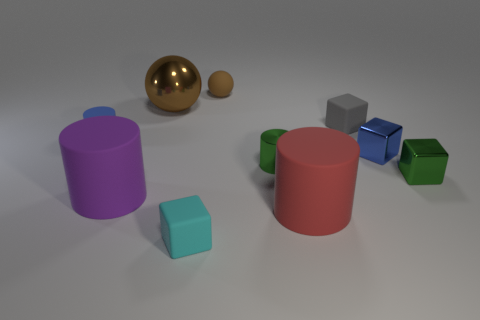Subtract 1 cubes. How many cubes are left? 3 Subtract all balls. How many objects are left? 8 Add 6 large brown metallic spheres. How many large brown metallic spheres exist? 7 Subtract 1 green cylinders. How many objects are left? 9 Subtract all purple things. Subtract all metallic blocks. How many objects are left? 7 Add 9 small gray rubber objects. How many small gray rubber objects are left? 10 